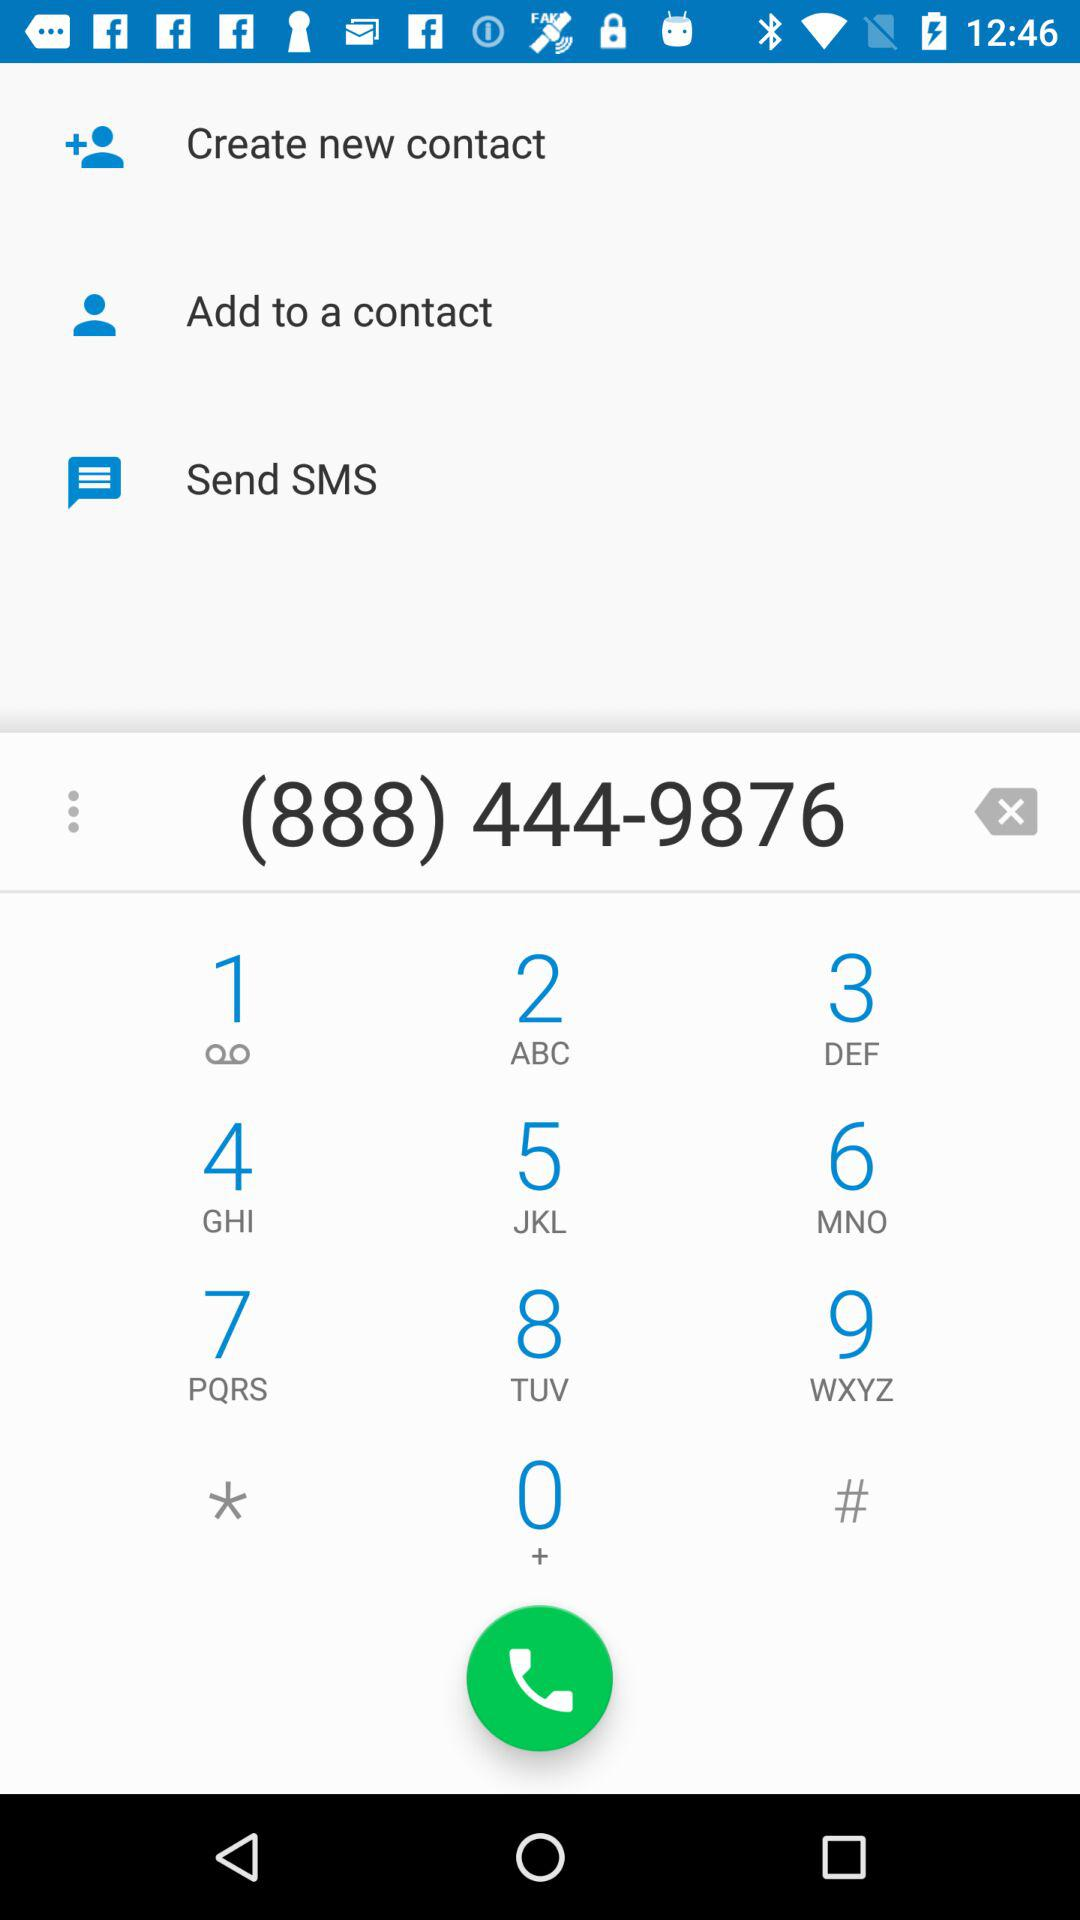What is the phone number? The phone number is (888) 444-9876. 